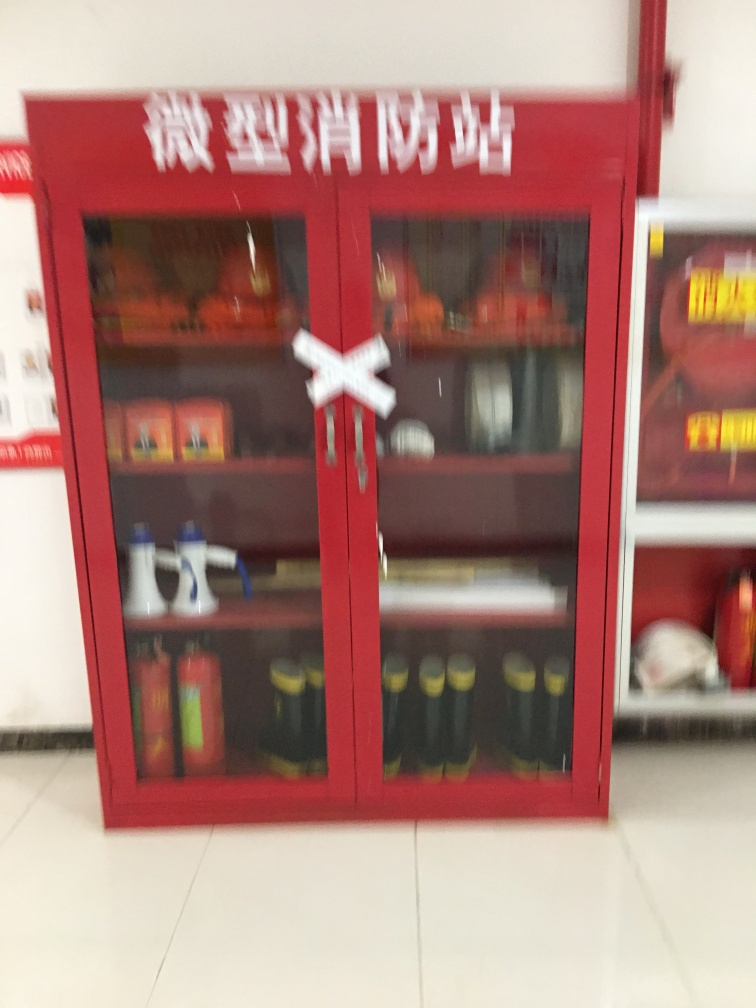What has happened to the texture details of the fire station? Based on the provided image, it appears that the texture details of the objects within the fire station have become less distinct, which may be a result of the image being blurred or out of focus. This loss of clarity means that finer details are not readily visible, hence we can conclude that option D (Almost all texture details are lost) is the most accurate description of the image's condition. 